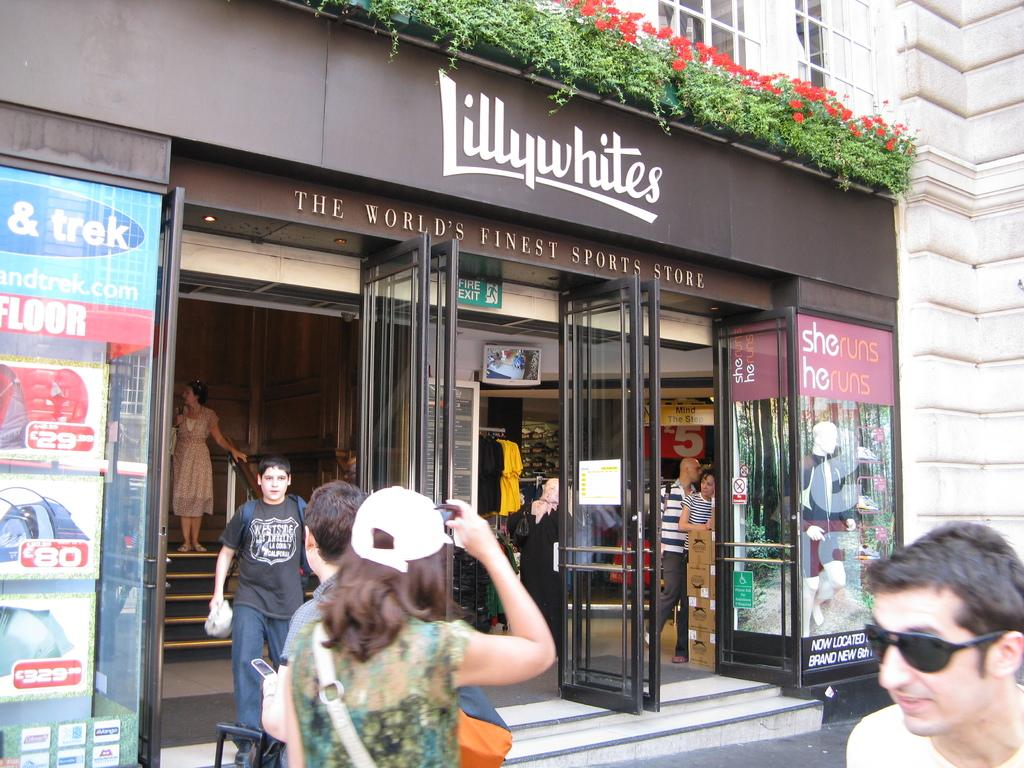What are the people in the image doing? The people in the image are standing in front of a store. What is the name of the store? The store has "Lillywhites" written on it. What can be seen above the store? There are plants above the store. What is visible in the background of the image? There is a building in the background of the image. What type of protest is taking place in front of the store? There is no protest visible in the image; it shows people standing in front of a store. Can you tell me how many plates are on display in the store window? There is no information about plates or any store window in the image. 